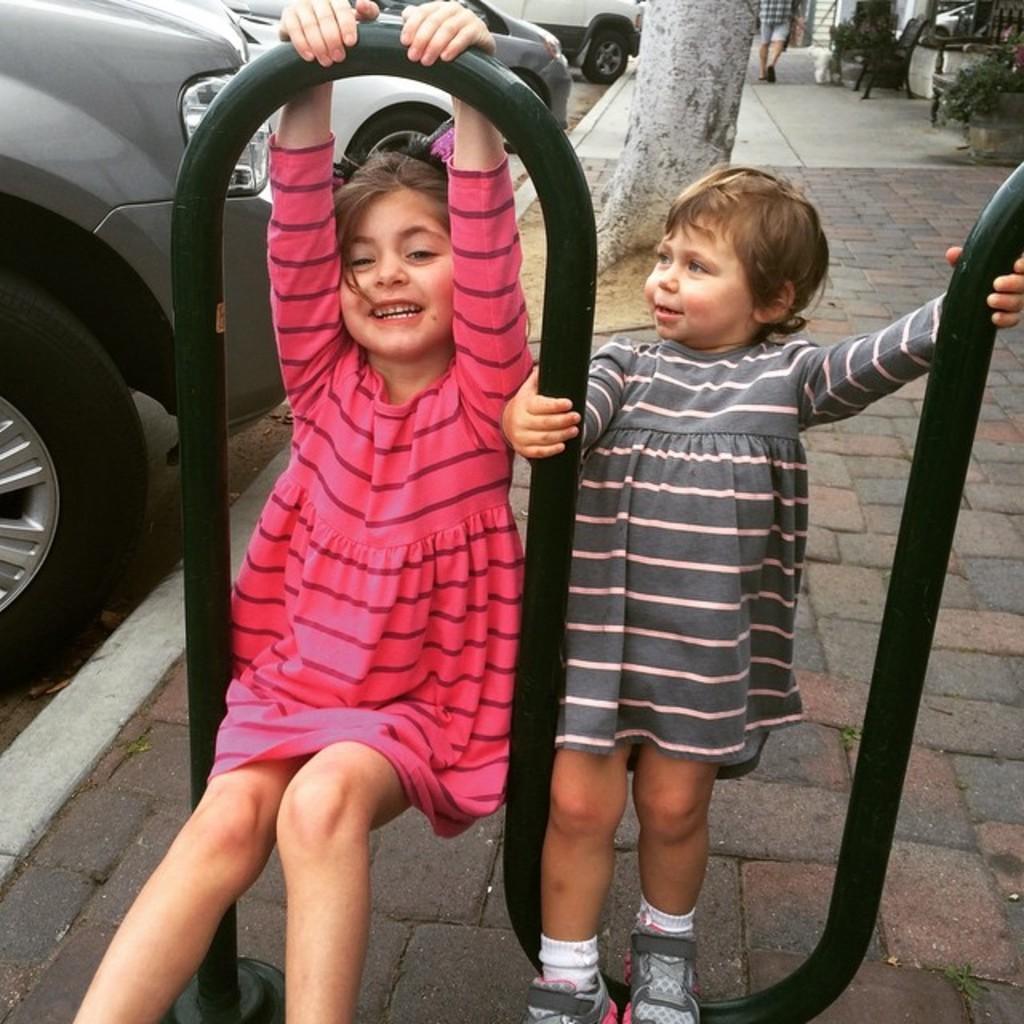In one or two sentences, can you explain what this image depicts? In this image, we can see two kids and there are some cars, we can see a person walking in the background. 